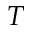<formula> <loc_0><loc_0><loc_500><loc_500>T</formula> 